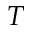<formula> <loc_0><loc_0><loc_500><loc_500>T</formula> 